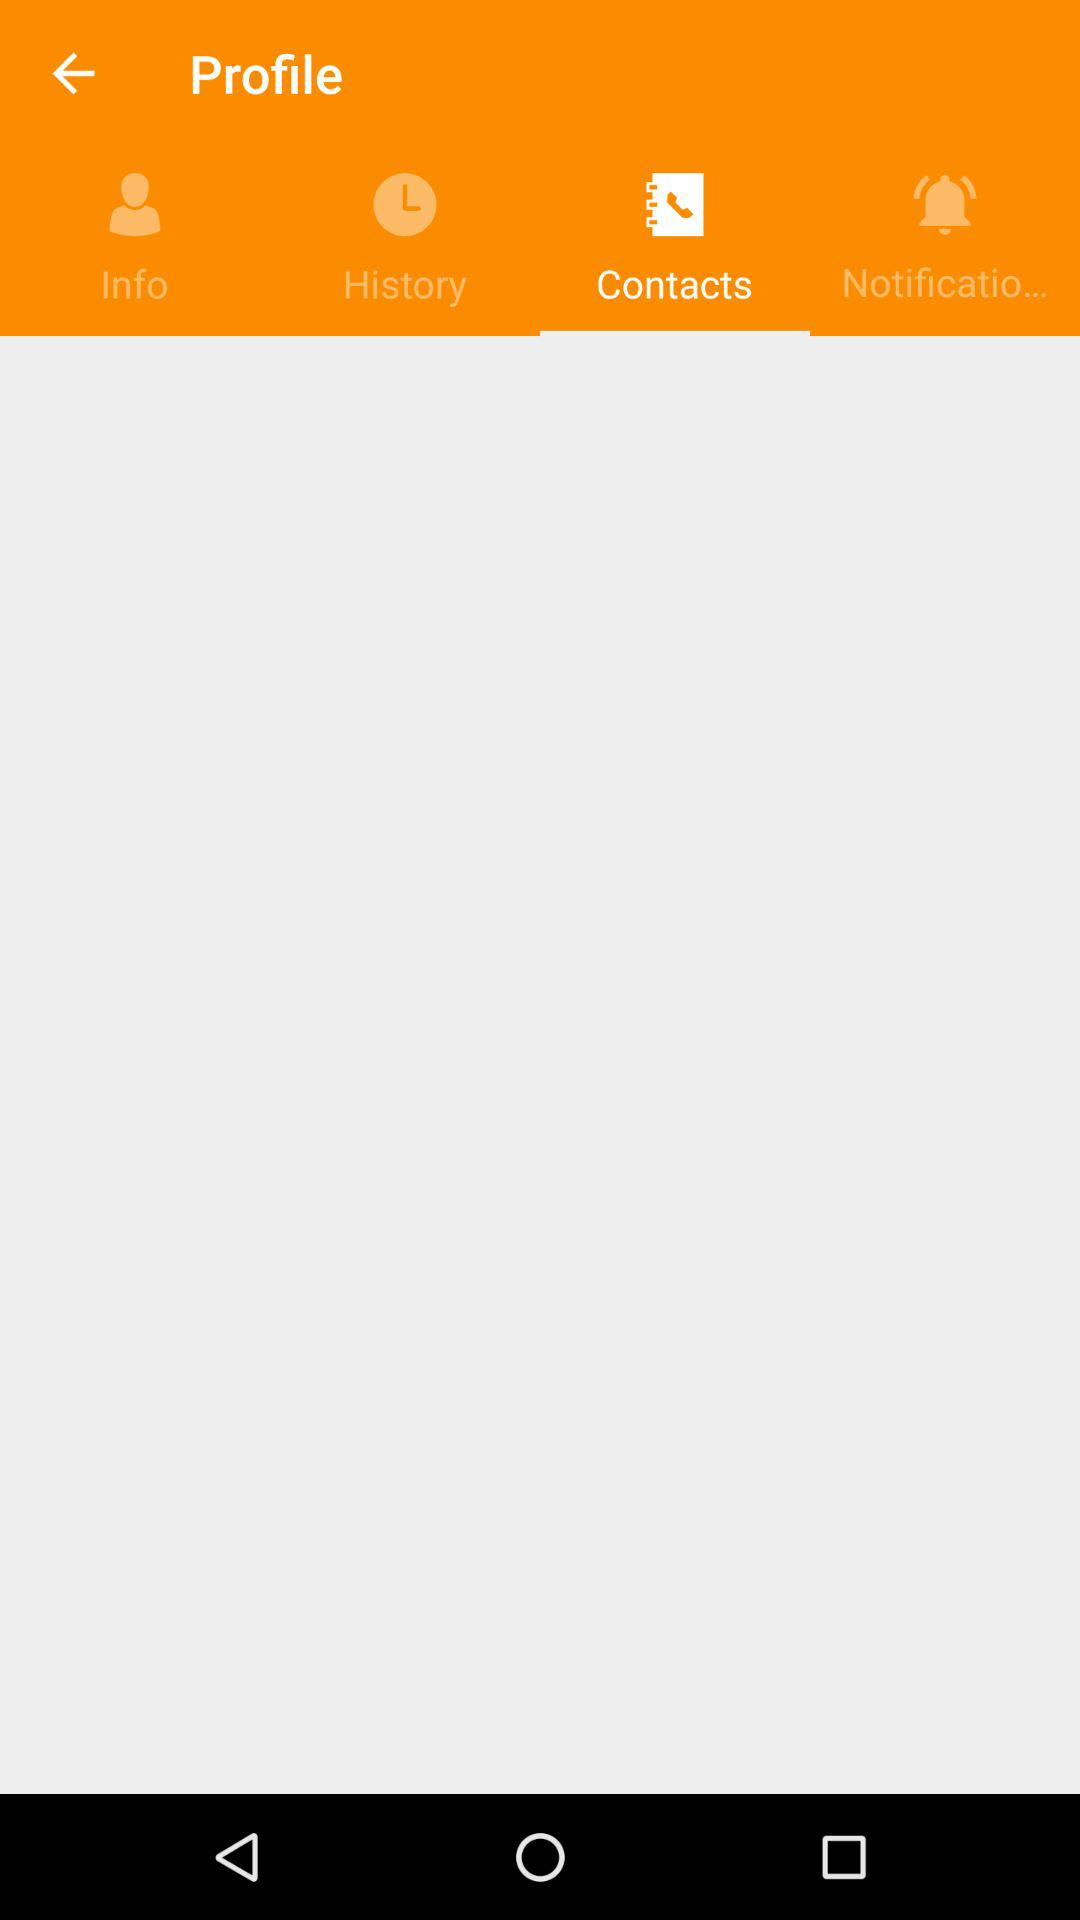Which tab is selected? The selected tab is "Contacts". 